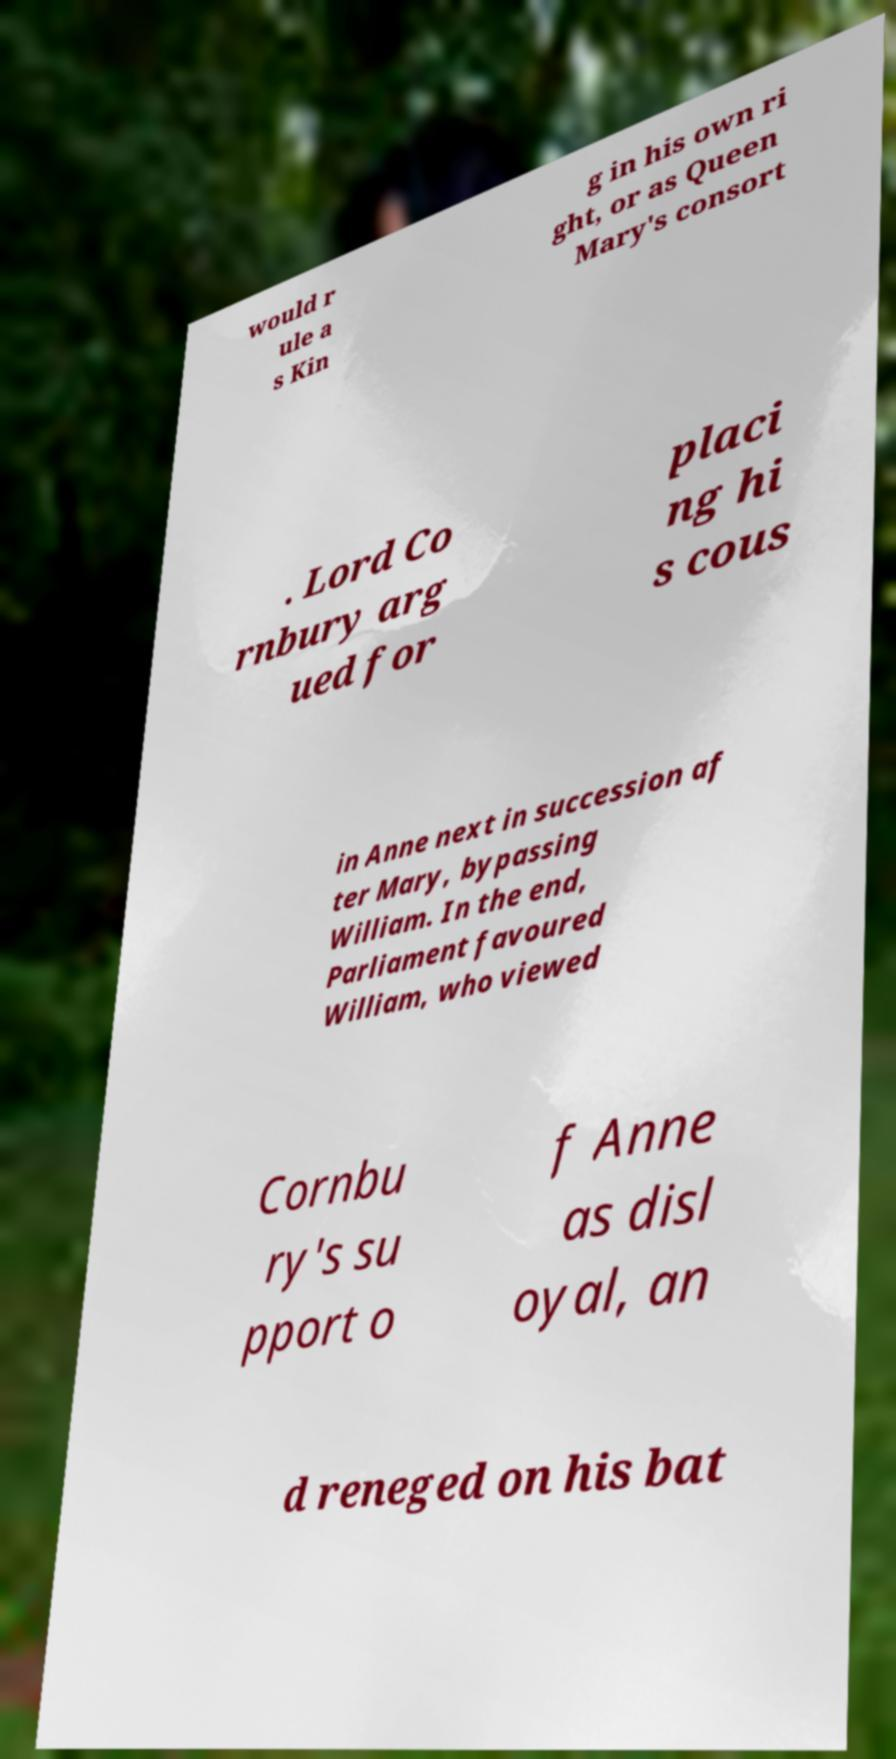Could you assist in decoding the text presented in this image and type it out clearly? would r ule a s Kin g in his own ri ght, or as Queen Mary's consort . Lord Co rnbury arg ued for placi ng hi s cous in Anne next in succession af ter Mary, bypassing William. In the end, Parliament favoured William, who viewed Cornbu ry's su pport o f Anne as disl oyal, an d reneged on his bat 